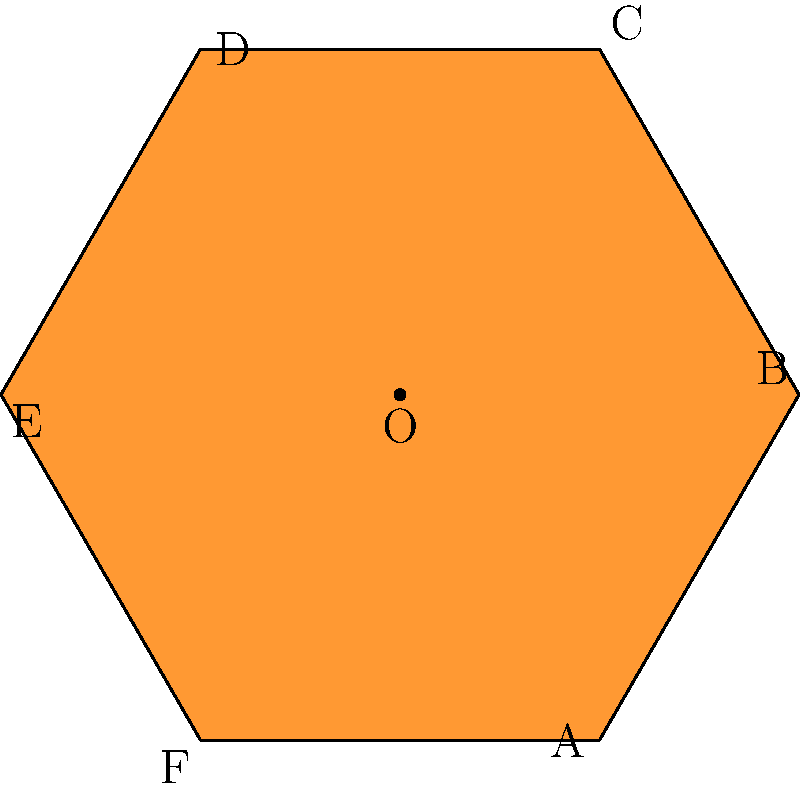In this traditional Venezuelan art pattern, two regular hexagons are overlapped. If $\overline{AB}$ is congruent to $\overline{CD}$, what is the measure of angle $\angle AOD$? Let's approach this step-by-step:

1) In a regular hexagon, all sides are congruent and all interior angles measure 120°.

2) The two hexagons are rotated 60° with respect to each other, sharing a center point O.

3) Since $\overline{AB}$ is congruent to $\overline{CD}$, we know that $\triangle AOB \cong \triangle COD$ (Side-Side-Side congruence).

4) In a regular hexagon, the central angle subtended by each side is 60°. Therefore, $\angle AOB = 60°$.

5) Since $\triangle AOB \cong \triangle COD$, we know that $\angle AOB = \angle COD = 60°$.

6) $\angle AOD$ is composed of $\angle AOB$ and $\angle BOC$.

7) $\angle BOC$ is the angle of rotation between the two hexagons, which is given as 60°.

8) Therefore, $\angle AOD = \angle AOB + \angle BOC = 60° + 60° = 120°$.
Answer: 120° 